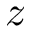<formula> <loc_0><loc_0><loc_500><loc_500>z</formula> 